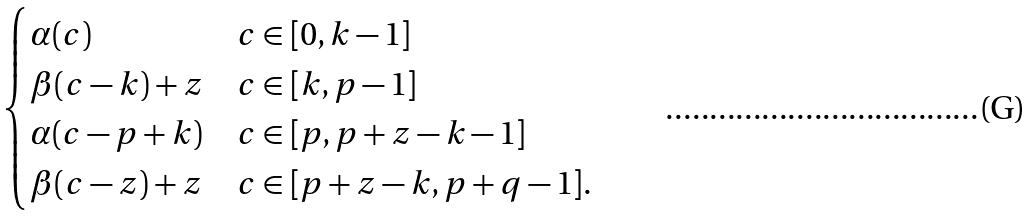<formula> <loc_0><loc_0><loc_500><loc_500>\begin{cases} \alpha ( c ) & c \in [ 0 , k - 1 ] \\ \beta ( c - k ) + z & c \in [ k , p - 1 ] \\ \alpha ( c - p + k ) & c \in [ p , p + z - k - 1 ] \\ \beta ( c - z ) + z & c \in [ p + z - k , p + q - 1 ] . \end{cases}</formula> 